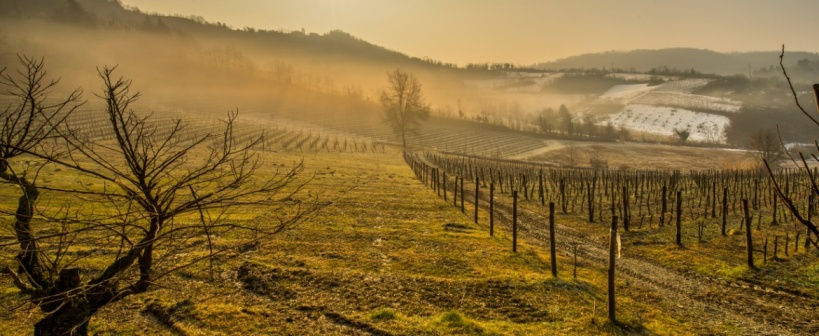Analyze the image in a comprehensive and detailed manner.
 This image captures a panoramic view of a vineyard nestled in a hilly landscape. The vineyard, situated on a slope, is composed of numerous rows of grapevines that curve around the contours of the hill. The grapevines, currently bare without any leaves or grapes, are arranged in an orderly fashion, creating a pattern that is both repetitive and mesmerizing. 

The photograph is taken from a high vantage point, providing a bird's eye view of the vineyard and the surrounding landscape. This perspective allows for a comprehensive view of the vineyard and its layout. 

The time of day appears to be early morning, as indicated by the rising sun that casts a soft light over the landscape. The sky, a pale blue, provides a stark contrast to the predominantly brown and green hues of the vineyard and the hills. A thin layer of fog blankets the hills, adding a touch of mystery to the scene.

Despite the absence of any human activity, the image conveys a sense of tranquility and serenity, characteristic of vineyards in the early hours of the day. The vineyard, with its neatly arranged rows of grapevines, stands as a testament to human ingenuity and the art of winemaking. 

Overall, the image provides a detailed and comprehensive view of a vineyard in the early morning, capturing the beauty and tranquility of the landscape. 